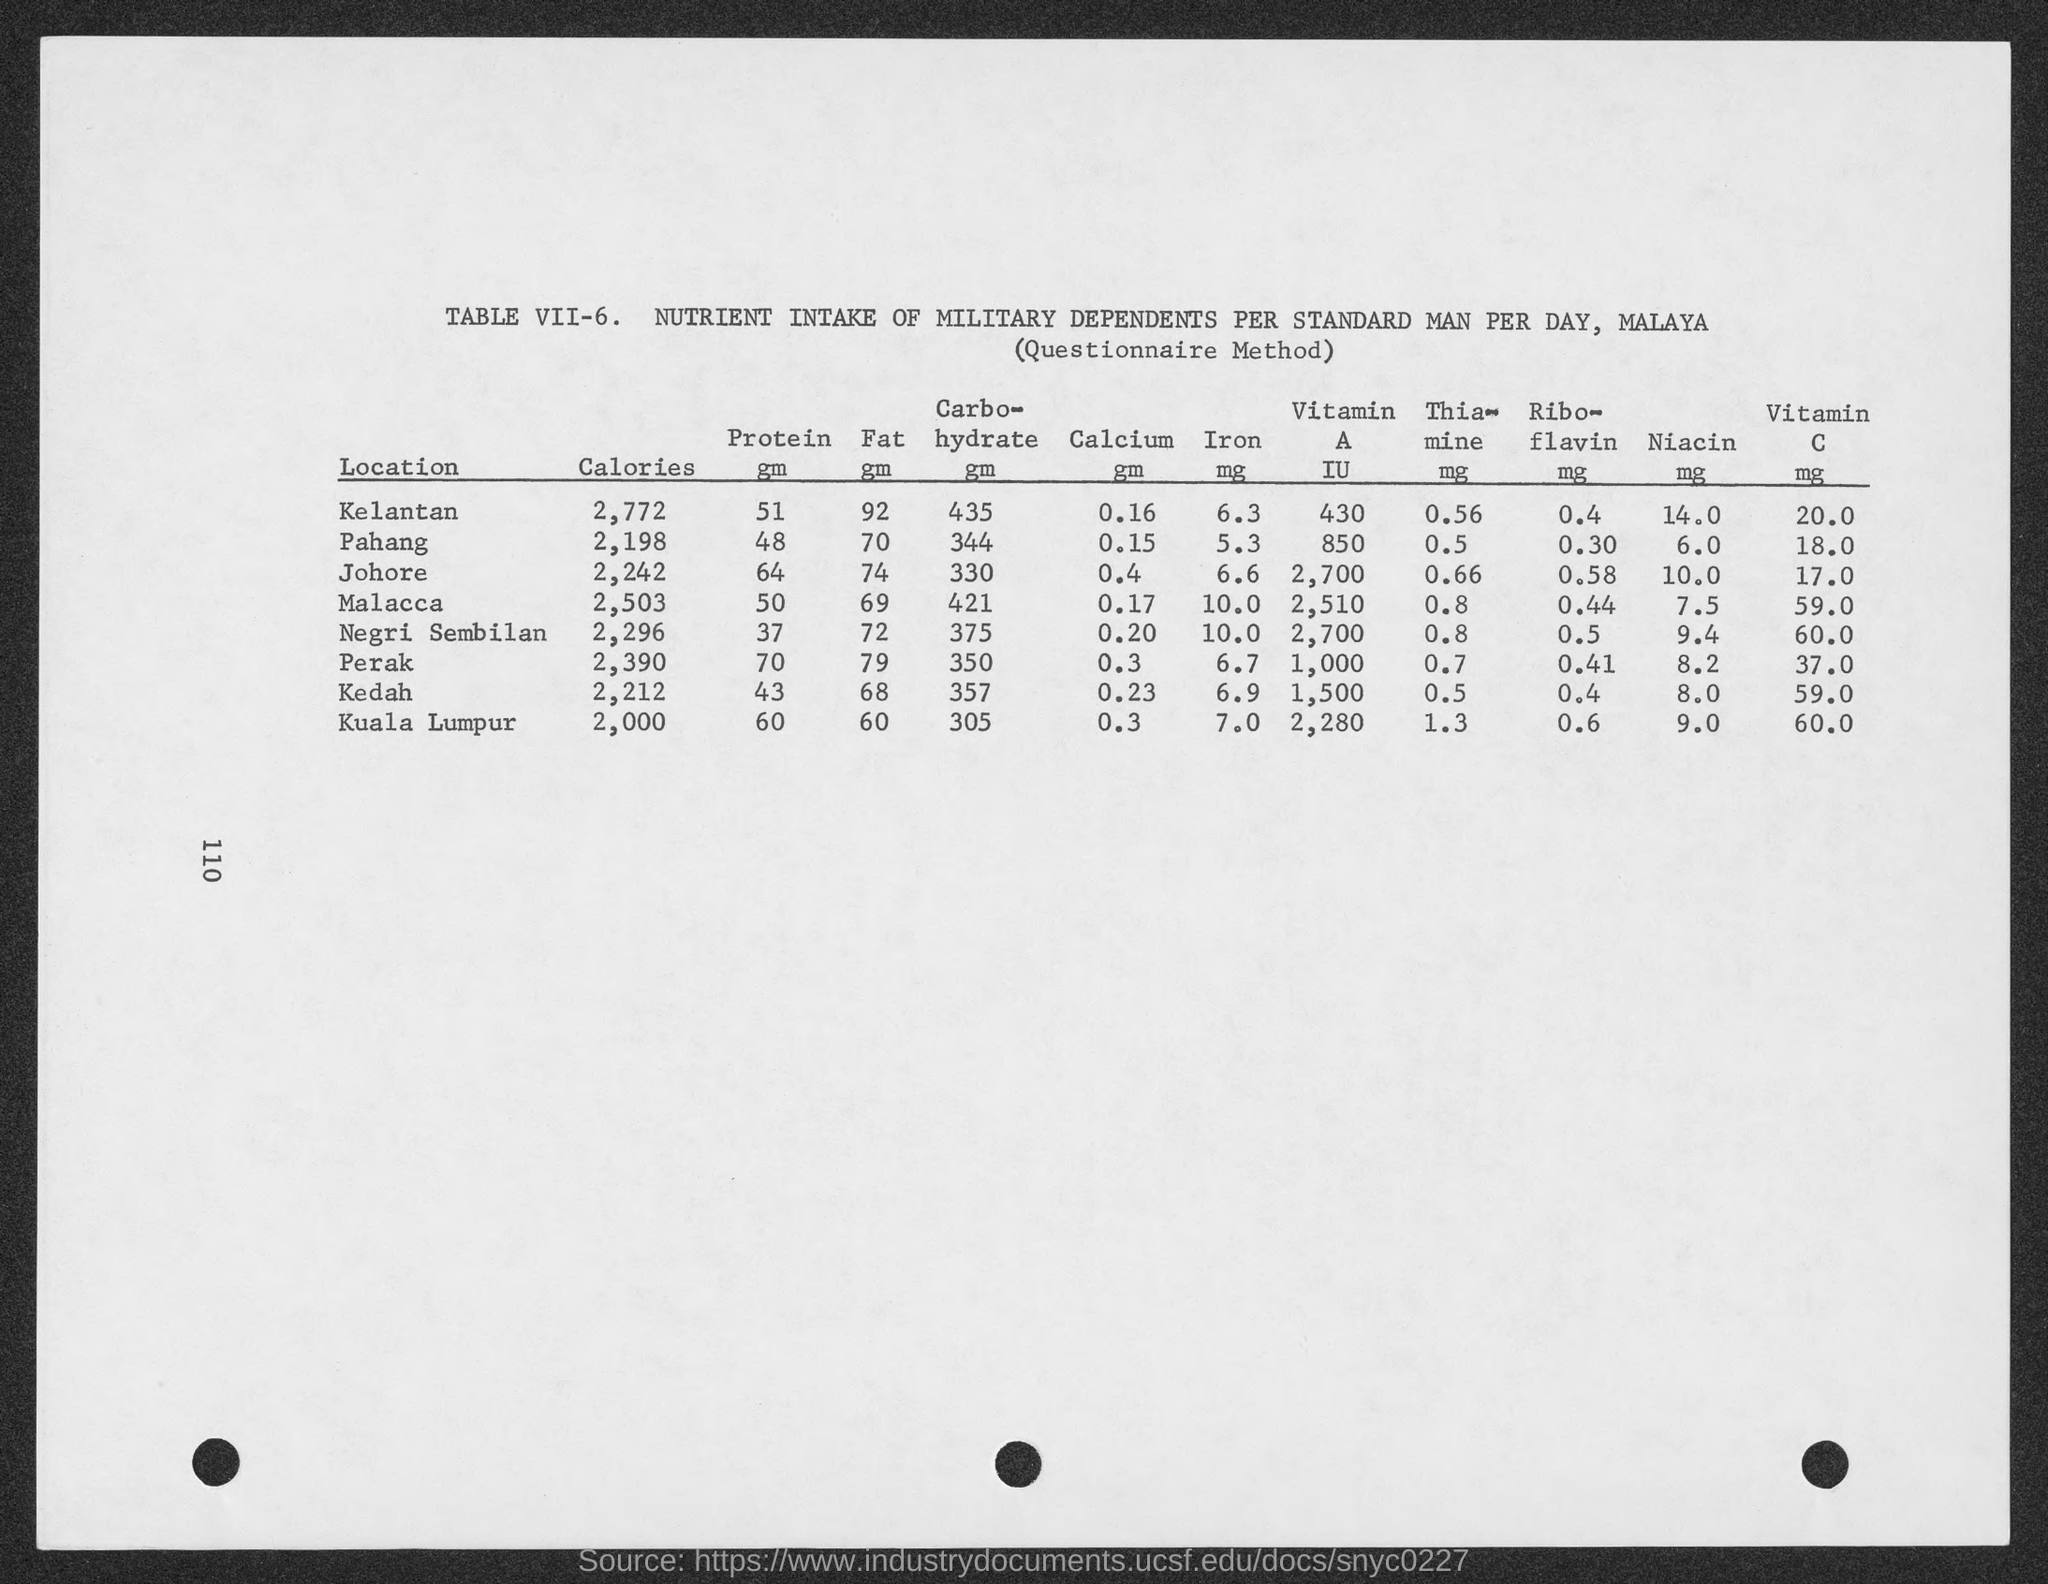What is the amount of calories intake of military dependent per stand man per day in kelantan?
Offer a very short reply. 2,772. What is the amount of calories intake of military dependent per stand man per day in pahang?
Offer a very short reply. 2,198. What is the amount of calories intake of military dependent per stand man per day in johore ?
Keep it short and to the point. 2,242. What is the amount of calories intake of military dependent per stand man per day in malacca ?
Provide a succinct answer. 2,503. What is the amount of calories intake of military dependent per stand man per day in negri sembilan ?
Ensure brevity in your answer.  2,296. What is the amount of calories intake of military dependent per stand man per day in perak?
Ensure brevity in your answer.  2,390. What is the amount of calories intake of military dependent per stand man per day  in kedah ?
Make the answer very short. 2,212. What is the amount of calories intake of military dependent per stand man per day  in kuala lumpur ??
Make the answer very short. 2,000. What is the amount of protein  intake of military dependent per stand man per day in kelantan?
Offer a terse response. 51 gm. 